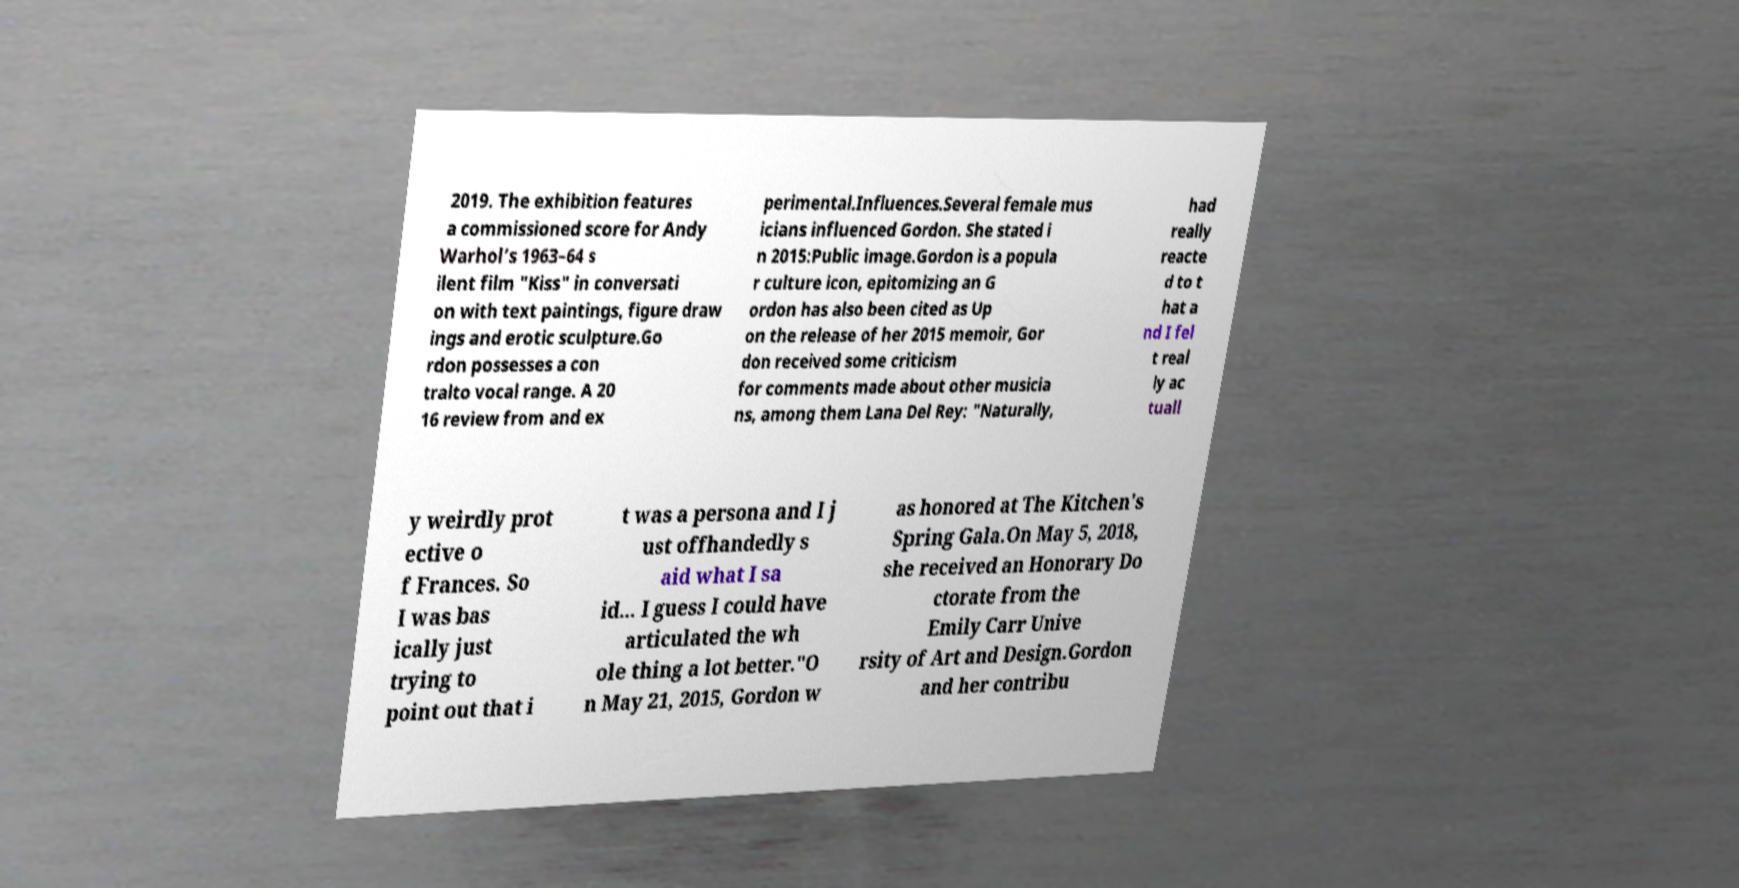Could you extract and type out the text from this image? 2019. The exhibition features a commissioned score for Andy Warhol’s 1963–64 s ilent film "Kiss" in conversati on with text paintings, figure draw ings and erotic sculpture.Go rdon possesses a con tralto vocal range. A 20 16 review from and ex perimental.Influences.Several female mus icians influenced Gordon. She stated i n 2015:Public image.Gordon is a popula r culture icon, epitomizing an G ordon has also been cited as Up on the release of her 2015 memoir, Gor don received some criticism for comments made about other musicia ns, among them Lana Del Rey: "Naturally, had really reacte d to t hat a nd I fel t real ly ac tuall y weirdly prot ective o f Frances. So I was bas ically just trying to point out that i t was a persona and I j ust offhandedly s aid what I sa id... I guess I could have articulated the wh ole thing a lot better."O n May 21, 2015, Gordon w as honored at The Kitchen's Spring Gala.On May 5, 2018, she received an Honorary Do ctorate from the Emily Carr Unive rsity of Art and Design.Gordon and her contribu 